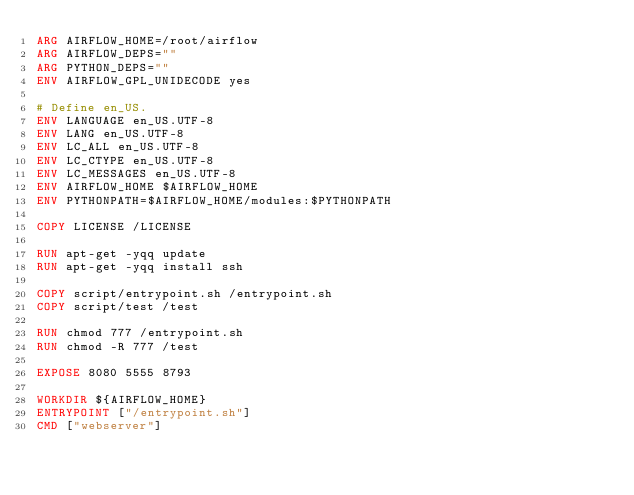Convert code to text. <code><loc_0><loc_0><loc_500><loc_500><_Dockerfile_>ARG AIRFLOW_HOME=/root/airflow
ARG AIRFLOW_DEPS=""
ARG PYTHON_DEPS=""
ENV AIRFLOW_GPL_UNIDECODE yes

# Define en_US.
ENV LANGUAGE en_US.UTF-8
ENV LANG en_US.UTF-8
ENV LC_ALL en_US.UTF-8
ENV LC_CTYPE en_US.UTF-8
ENV LC_MESSAGES en_US.UTF-8
ENV AIRFLOW_HOME $AIRFLOW_HOME
ENV PYTHONPATH=$AIRFLOW_HOME/modules:$PYTHONPATH

COPY LICENSE /LICENSE

RUN apt-get -yqq update
RUN apt-get -yqq install ssh

COPY script/entrypoint.sh /entrypoint.sh
COPY script/test /test

RUN chmod 777 /entrypoint.sh
RUN chmod -R 777 /test

EXPOSE 8080 5555 8793

WORKDIR ${AIRFLOW_HOME}
ENTRYPOINT ["/entrypoint.sh"]
CMD ["webserver"]
</code> 